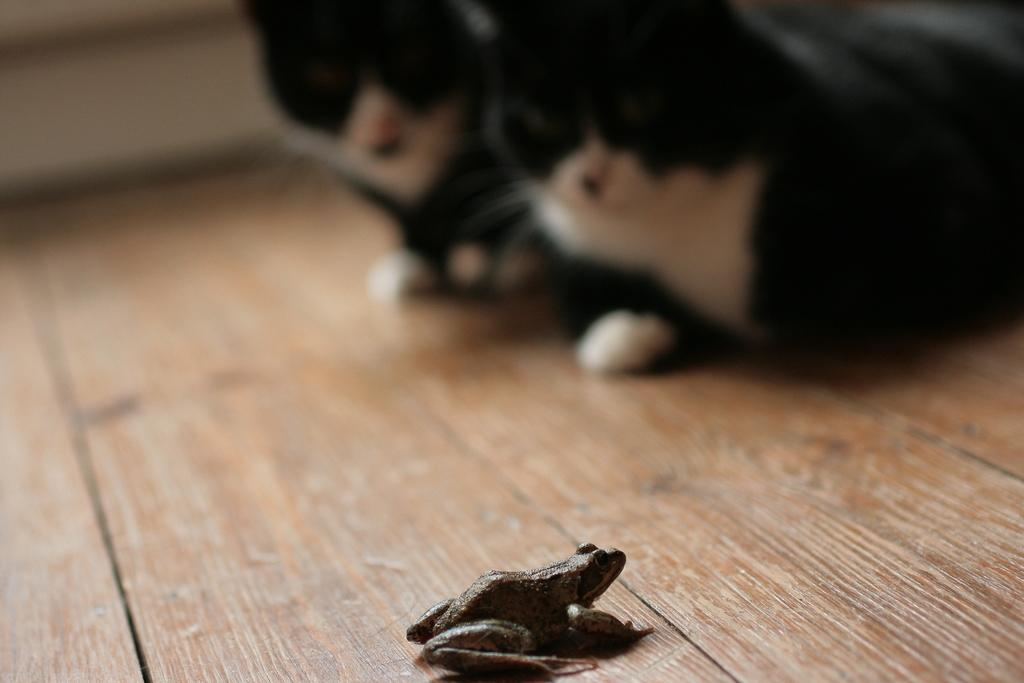What type of animal is in the image? There is a frog in the image. How many animals are on the wooden platform in the image? There are two animals on the wooden platform in the image. Can you describe the background of the image? The background of the image is blurry. What type of bread is visible on the chessboard in the image? There is no bread or chessboard present in the image. 